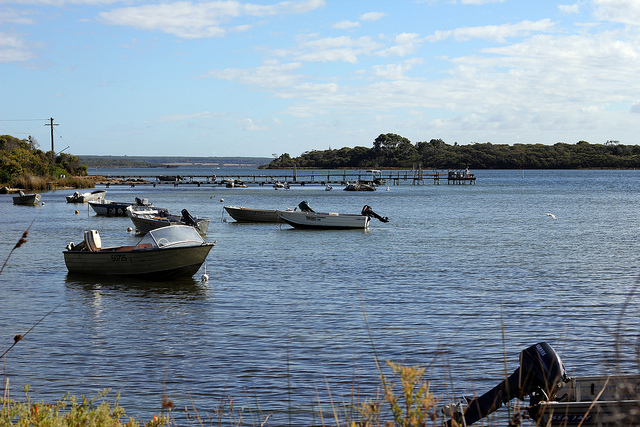Create a story involving the people who might use these boats regularly. On the shores of this serene lake, there lived a small community of fishermen who cherished their peaceful routines. Each morning before sunrise, they would gather at the docks, their laughter and friendly banter echoing in the stillness of dawn. They would set out in their boats, gliding over the calm waters to their favorite fishing spots, where they would spend hours immersed in the tranquility of nature. On weekends, families from the village would join them, packing picnic baskets and making a day of it. The boats were not just tools for their livelihood but symbols of their bond with each other and with the lake itself. Over the years, many stories were shared and memories made on these waters, weaving a rich tapestry of joy, love, and camaraderie. Evenings often found the villagers back at the dock, watching the sunset paint the skies in brilliant colors, grateful for yet another day spent in harmony with the world around them. 